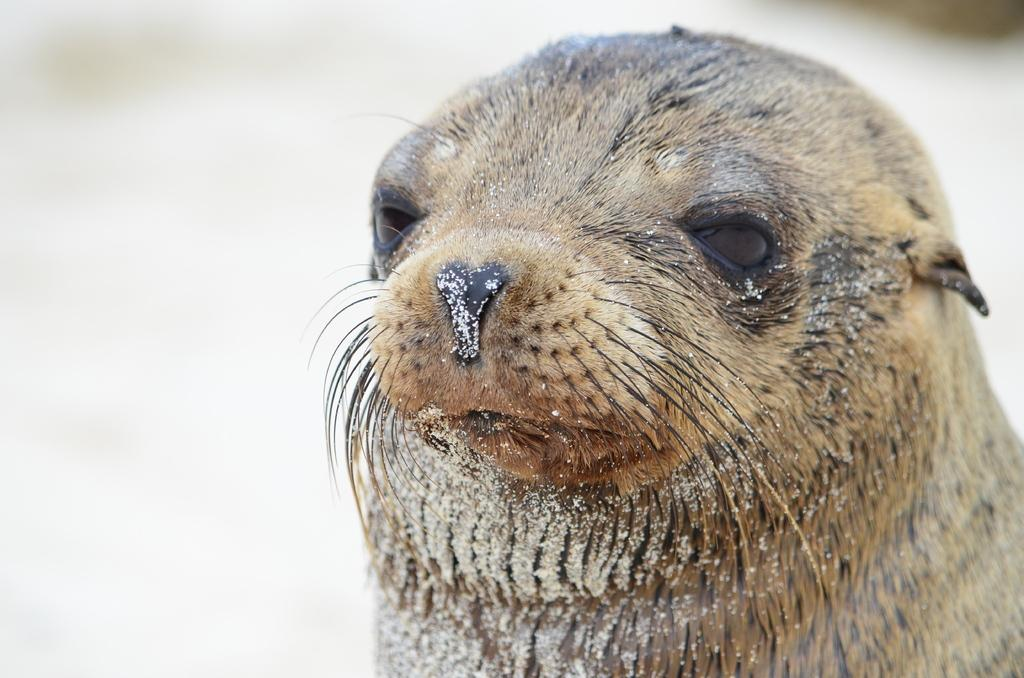What is the main subject in the foreground of the image? There is an animal in the foreground of the image. Can you describe the background of the image? The background of the image is blurred. What type of rhythm can be heard coming from the animal in the image? There is no sound or rhythm associated with the animal in the image, as it is a still photograph. 